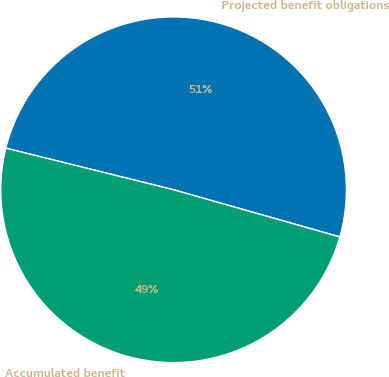<chart> <loc_0><loc_0><loc_500><loc_500><pie_chart><fcel>Projected benefit obligations<fcel>Accumulated benefit<nl><fcel>50.53%<fcel>49.47%<nl></chart> 